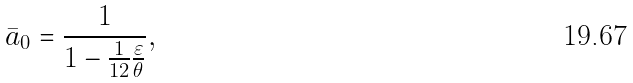Convert formula to latex. <formula><loc_0><loc_0><loc_500><loc_500>\bar { a } _ { 0 } = \frac { 1 } { 1 - \frac { 1 } { 1 2 } \frac { \varepsilon } { \theta } } ,</formula> 